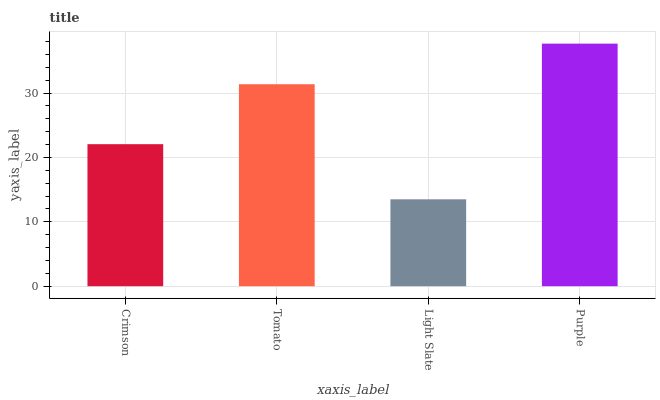Is Light Slate the minimum?
Answer yes or no. Yes. Is Purple the maximum?
Answer yes or no. Yes. Is Tomato the minimum?
Answer yes or no. No. Is Tomato the maximum?
Answer yes or no. No. Is Tomato greater than Crimson?
Answer yes or no. Yes. Is Crimson less than Tomato?
Answer yes or no. Yes. Is Crimson greater than Tomato?
Answer yes or no. No. Is Tomato less than Crimson?
Answer yes or no. No. Is Tomato the high median?
Answer yes or no. Yes. Is Crimson the low median?
Answer yes or no. Yes. Is Crimson the high median?
Answer yes or no. No. Is Tomato the low median?
Answer yes or no. No. 